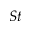<formula> <loc_0><loc_0><loc_500><loc_500>S t</formula> 